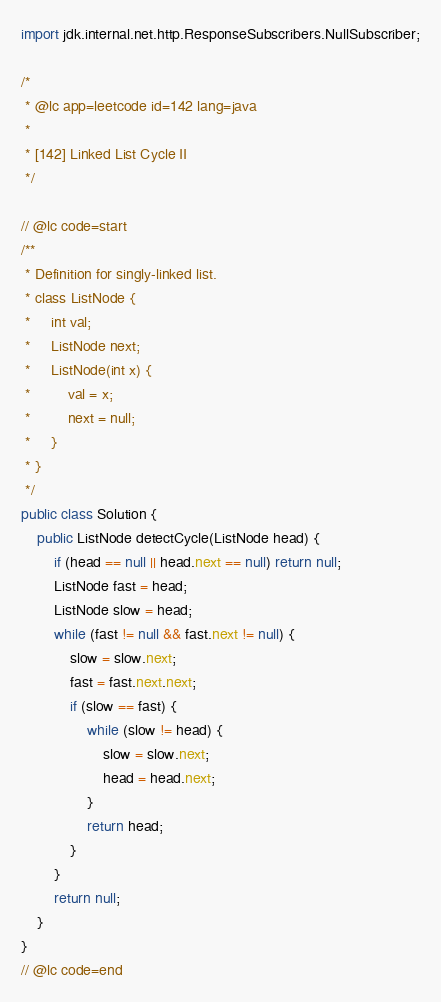Convert code to text. <code><loc_0><loc_0><loc_500><loc_500><_Java_>import jdk.internal.net.http.ResponseSubscribers.NullSubscriber;

/*
 * @lc app=leetcode id=142 lang=java
 *
 * [142] Linked List Cycle II
 */

// @lc code=start
/**
 * Definition for singly-linked list.
 * class ListNode {
 *     int val;
 *     ListNode next;
 *     ListNode(int x) {
 *         val = x;
 *         next = null;
 *     }
 * }
 */
public class Solution {
    public ListNode detectCycle(ListNode head) {
        if (head == null || head.next == null) return null;
        ListNode fast = head;
        ListNode slow = head;
        while (fast != null && fast.next != null) {
            slow = slow.next;
            fast = fast.next.next;
            if (slow == fast) {
                while (slow != head) {
                    slow = slow.next;
                    head = head.next;
                }
                return head;
            }
        }
        return null;
    }
}
// @lc code=end

</code> 